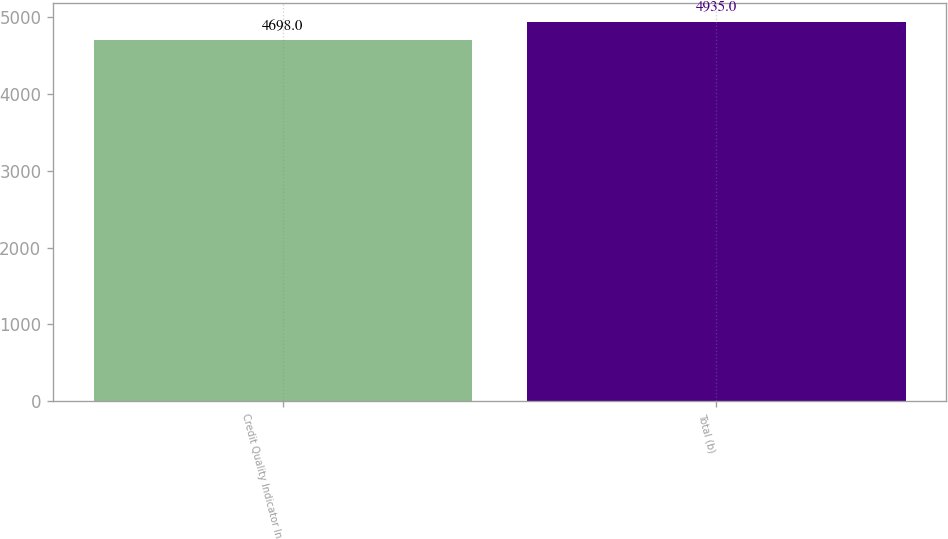Convert chart to OTSL. <chart><loc_0><loc_0><loc_500><loc_500><bar_chart><fcel>Credit Quality Indicator In<fcel>Total (b)<nl><fcel>4698<fcel>4935<nl></chart> 